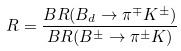<formula> <loc_0><loc_0><loc_500><loc_500>R = \frac { B R ( B _ { d } \to \pi ^ { \mp } K ^ { \pm } ) } { B R ( B ^ { \pm } \to \pi ^ { \pm } K ) }</formula> 